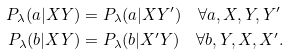Convert formula to latex. <formula><loc_0><loc_0><loc_500><loc_500>P _ { \lambda } ( a | X Y ) & = P _ { \lambda } ( a | X Y ^ { \prime } ) \quad \forall a , X , Y , Y ^ { \prime } \\ P _ { \lambda } ( b | X Y ) & = P _ { \lambda } ( b | X ^ { \prime } Y ) \quad \forall b , Y , X , X ^ { \prime } .</formula> 